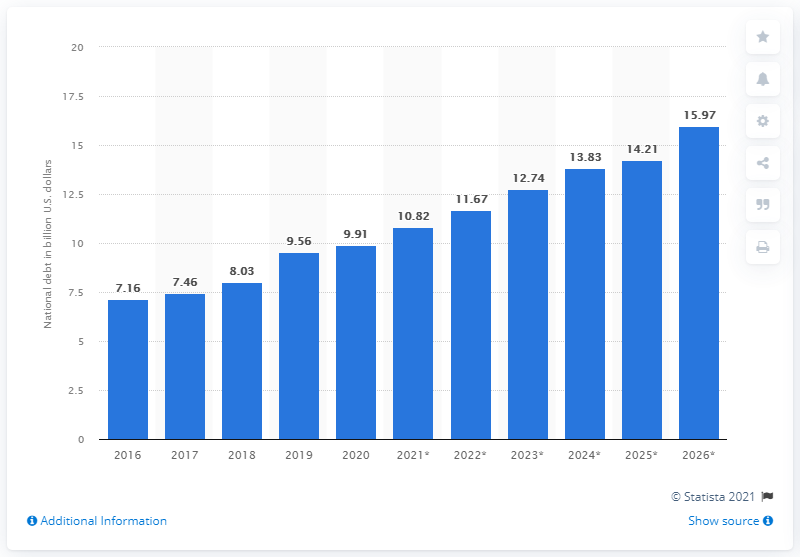Draw attention to some important aspects in this diagram. In 2020, the national debt of Mauritius was 9.91 dollars. 